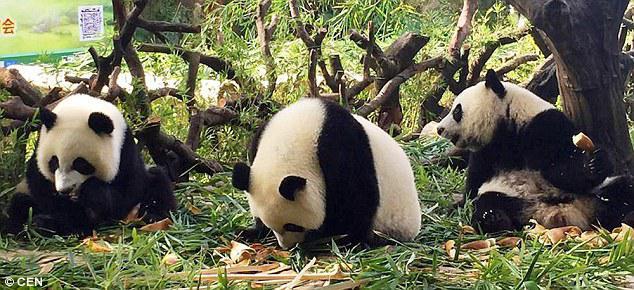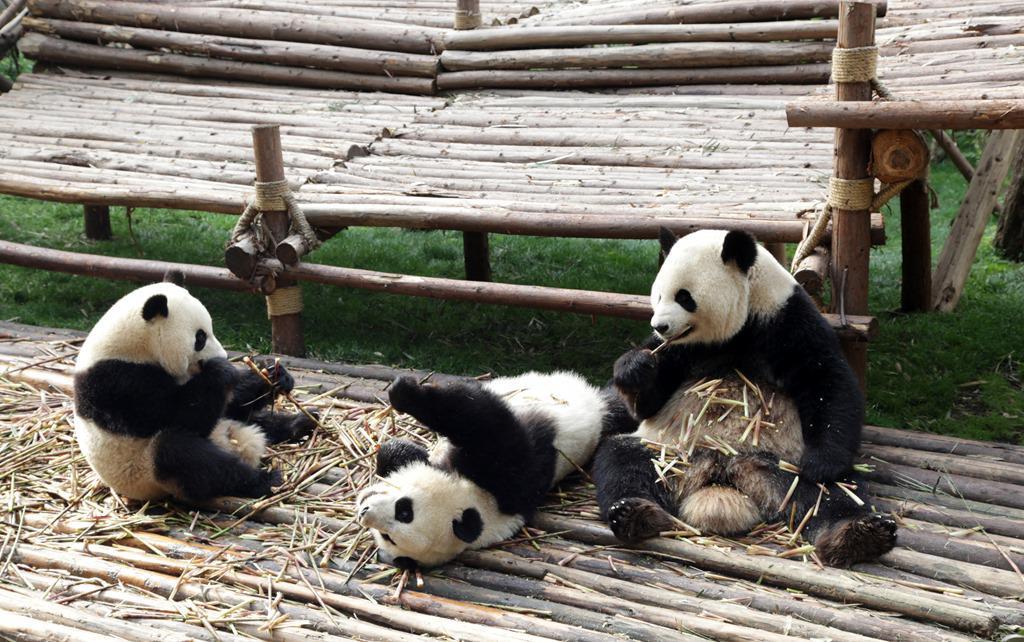The first image is the image on the left, the second image is the image on the right. Considering the images on both sides, is "Six pandas are sitting outside." valid? Answer yes or no. Yes. The first image is the image on the left, the second image is the image on the right. Evaluate the accuracy of this statement regarding the images: "There is no more than one panda in the right image.". Is it true? Answer yes or no. No. 